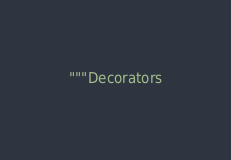<code> <loc_0><loc_0><loc_500><loc_500><_Python_>"""Decorators</code> 